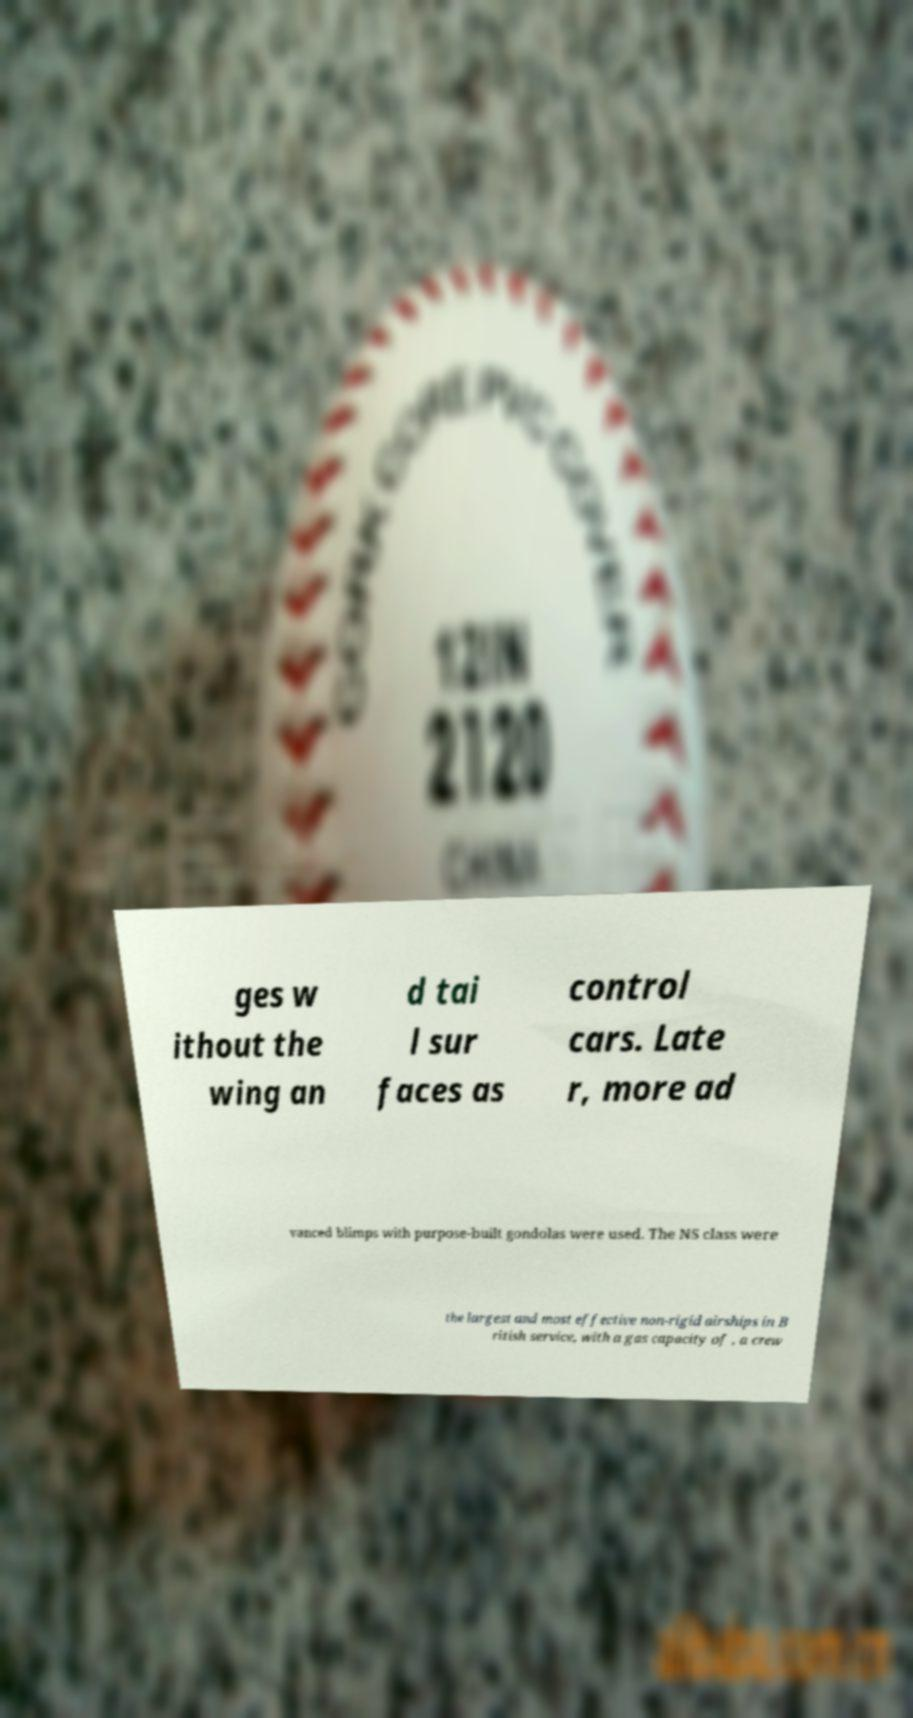Can you accurately transcribe the text from the provided image for me? ges w ithout the wing an d tai l sur faces as control cars. Late r, more ad vanced blimps with purpose-built gondolas were used. The NS class were the largest and most effective non-rigid airships in B ritish service, with a gas capacity of , a crew 